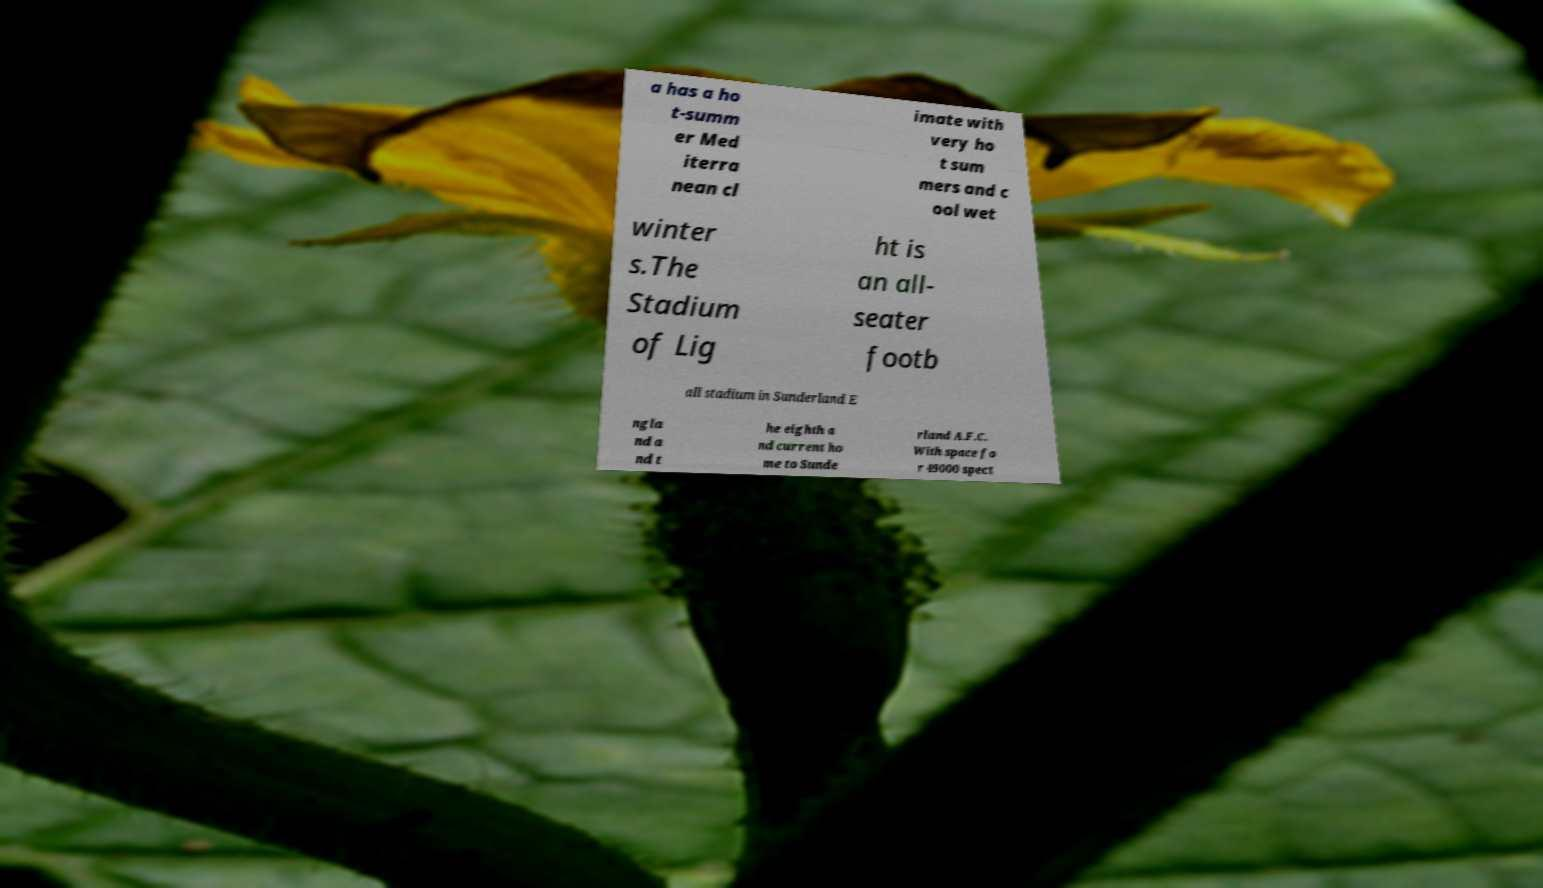I need the written content from this picture converted into text. Can you do that? a has a ho t-summ er Med iterra nean cl imate with very ho t sum mers and c ool wet winter s.The Stadium of Lig ht is an all- seater footb all stadium in Sunderland E ngla nd a nd t he eighth a nd current ho me to Sunde rland A.F.C. With space fo r 49000 spect 